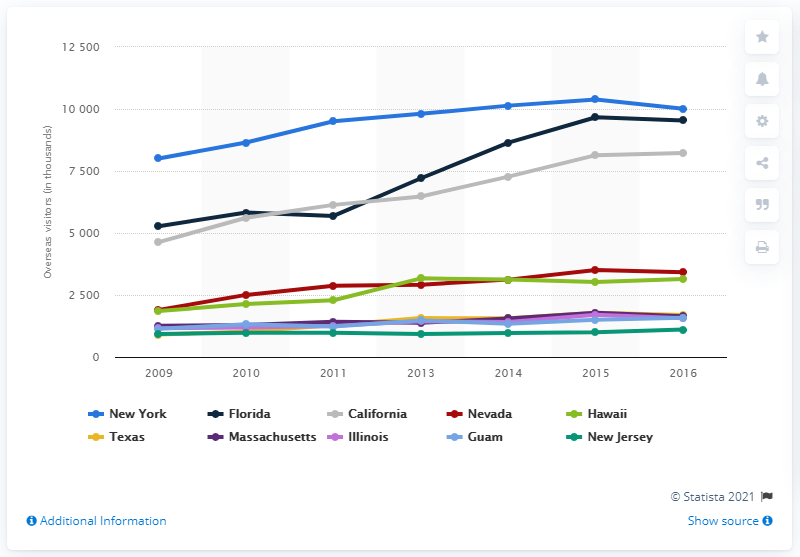Give some essential details in this illustration. In 2016, the most frequently chosen travel destination for overseas visitors was New York. 